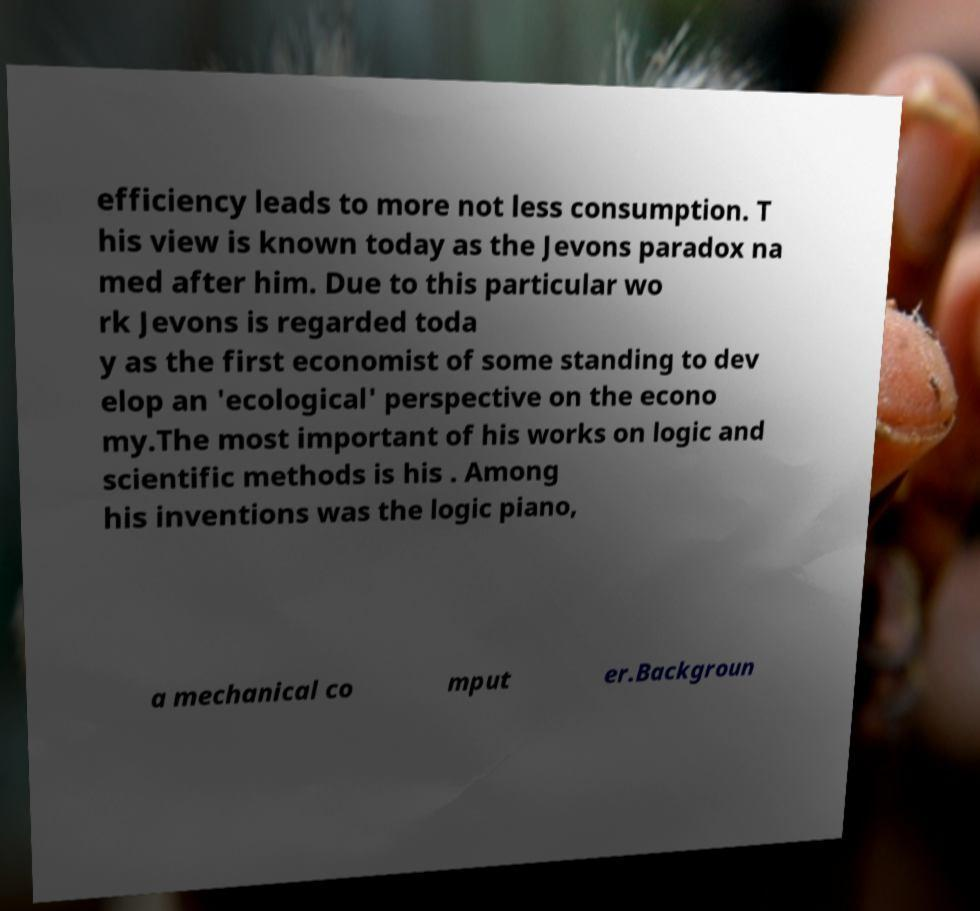What messages or text are displayed in this image? I need them in a readable, typed format. efficiency leads to more not less consumption. T his view is known today as the Jevons paradox na med after him. Due to this particular wo rk Jevons is regarded toda y as the first economist of some standing to dev elop an 'ecological' perspective on the econo my.The most important of his works on logic and scientific methods is his . Among his inventions was the logic piano, a mechanical co mput er.Backgroun 